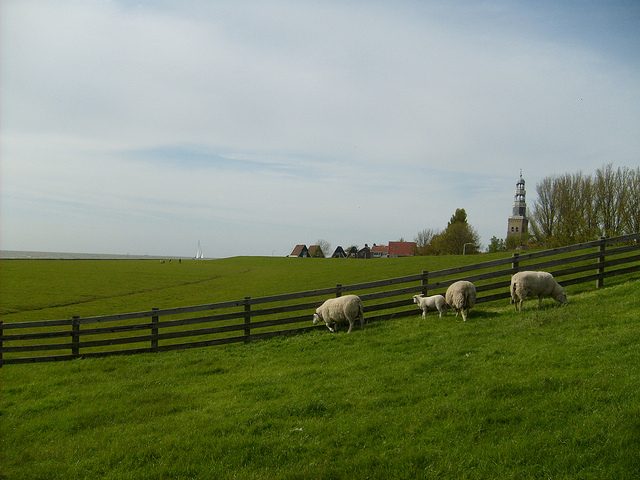<image>Which one is not with the group? It is ambiguous which one is not with the group. It could be the one on the left, right, or even the goat. Which one is not with the group? I don't know which one is not with the group. It can be either the goat or the sheep on the left. 